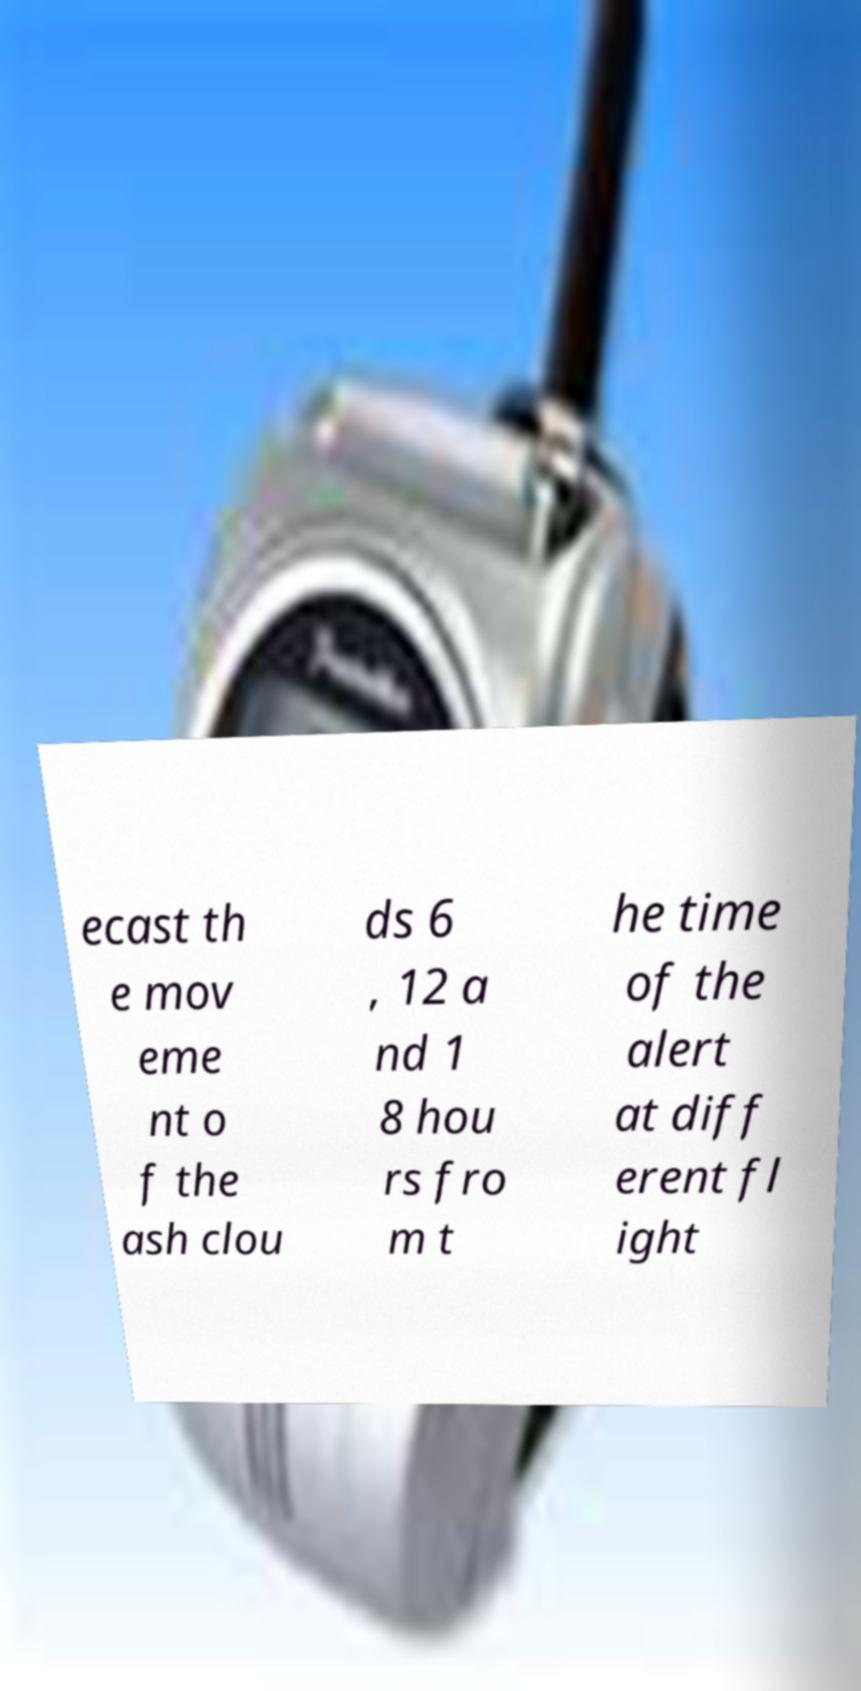Could you assist in decoding the text presented in this image and type it out clearly? ecast th e mov eme nt o f the ash clou ds 6 , 12 a nd 1 8 hou rs fro m t he time of the alert at diff erent fl ight 